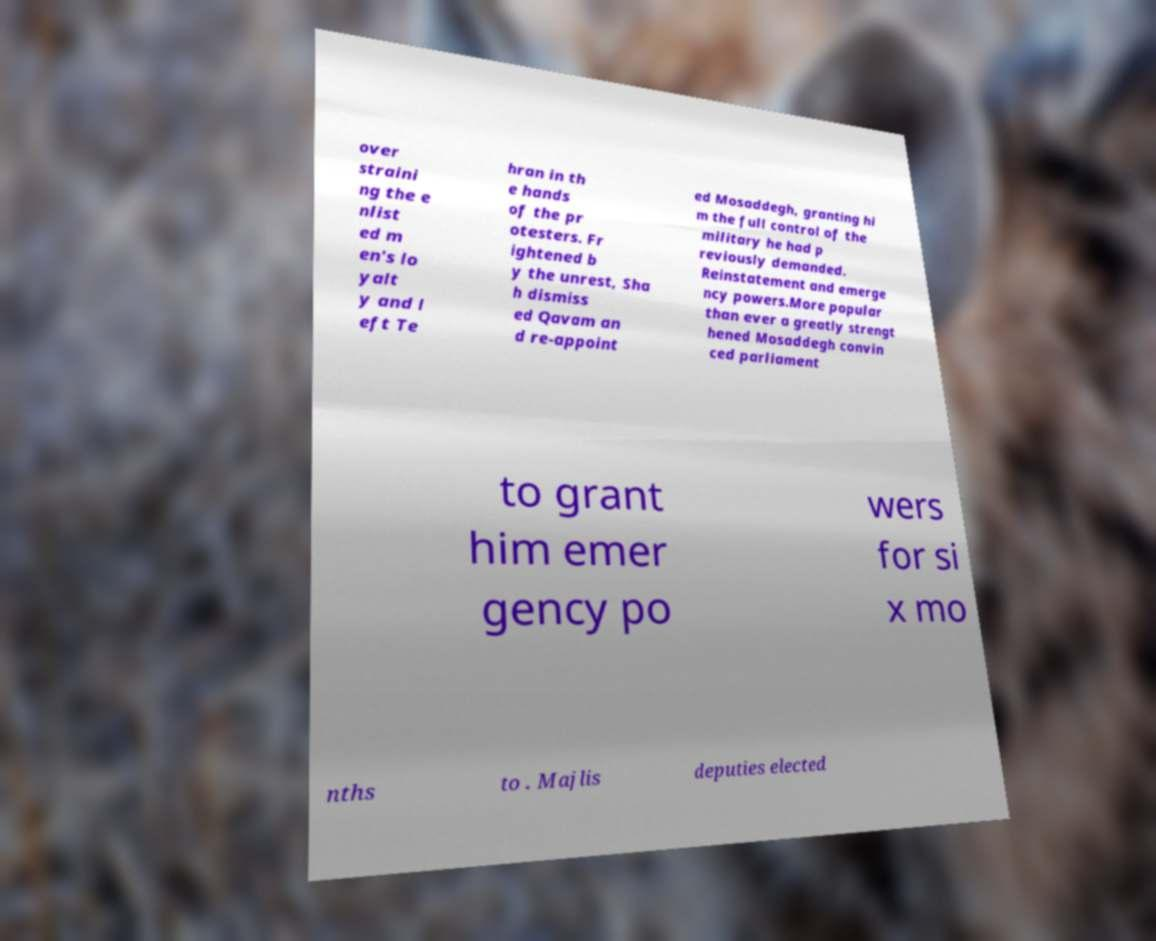Can you accurately transcribe the text from the provided image for me? over straini ng the e nlist ed m en's lo yalt y and l eft Te hran in th e hands of the pr otesters. Fr ightened b y the unrest, Sha h dismiss ed Qavam an d re-appoint ed Mosaddegh, granting hi m the full control of the military he had p reviously demanded. Reinstatement and emerge ncy powers.More popular than ever a greatly strengt hened Mosaddegh convin ced parliament to grant him emer gency po wers for si x mo nths to . Majlis deputies elected 